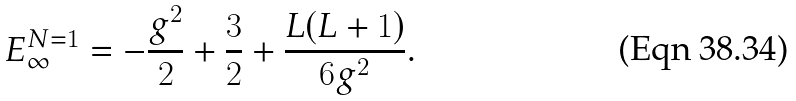<formula> <loc_0><loc_0><loc_500><loc_500>E _ { \infty } ^ { N = 1 } = - \frac { g ^ { 2 } } { 2 } + \frac { 3 } { 2 } + \frac { L ( L + 1 ) } { 6 g ^ { 2 } } .</formula> 